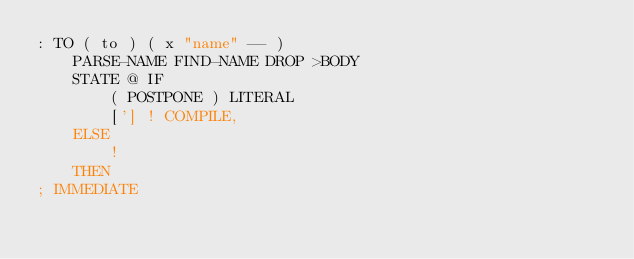Convert code to text. <code><loc_0><loc_0><loc_500><loc_500><_Forth_>: TO ( to ) ( x "name" -- )
	PARSE-NAME FIND-NAME DROP >BODY
	STATE @ IF
		( POSTPONE ) LITERAL
		['] ! COMPILE,
	ELSE
		!
	THEN
; IMMEDIATE
</code> 